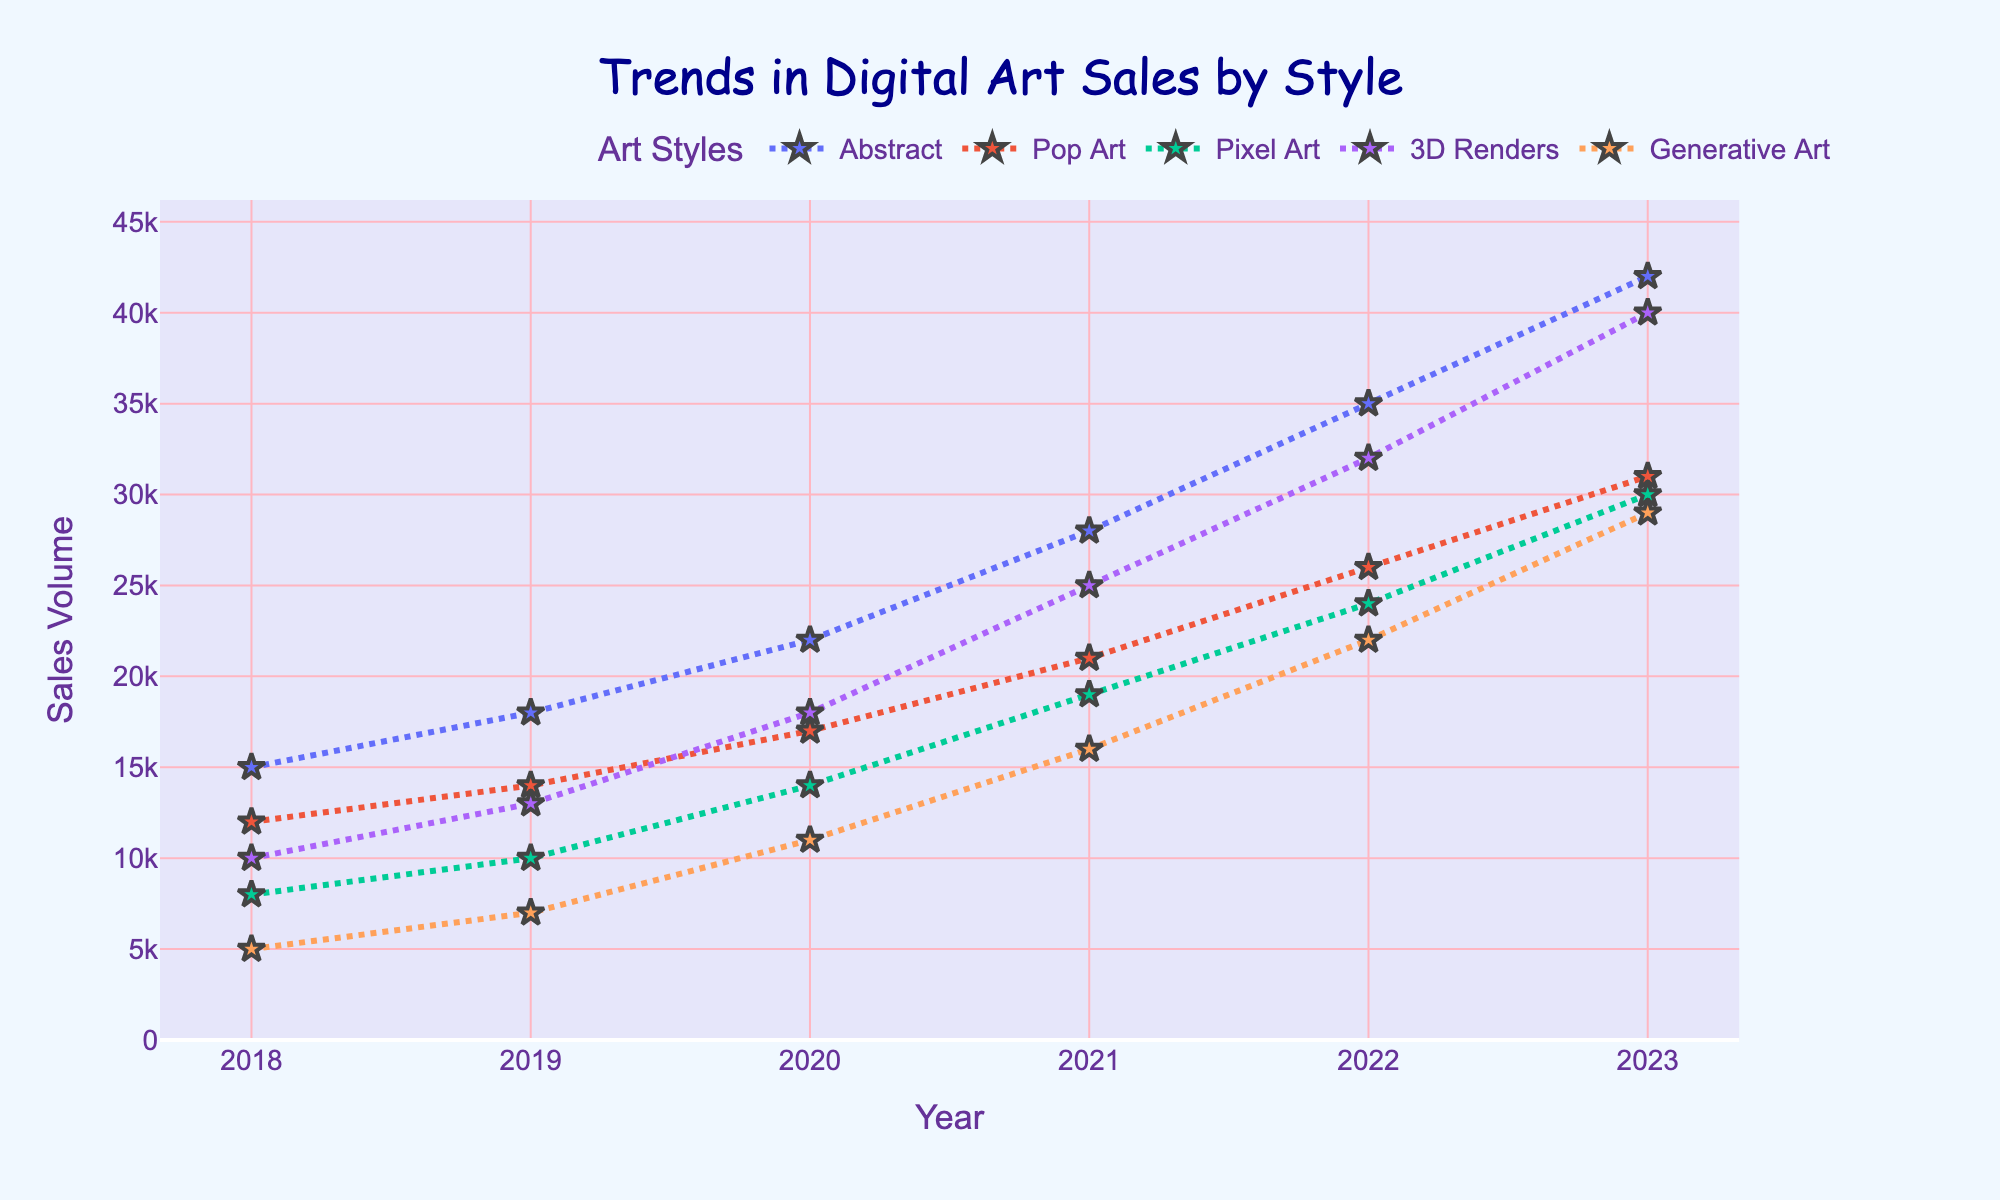What art style had the highest sales in 2023? The art style with the highest sales in 2023 is identified by looking at the peaks of the lines in the final year on the x-axis. The highest point corresponds to "3D Renders."
Answer: 3D Renders Which art style showed the most consistent growth from 2018 to 2023? Consistent growth is observed by seeing if the line graph for the art style steadily increases year-over-year without any declines. "Abstract" shows continuous and steady growth.
Answer: Abstract What is the difference in sales between Pixel Art and Generative Art in 2022? First, find the sales values for Pixel Art (24000) and Generative Art (22000) in 2022. Then calculate the difference: 24000 - 22000 = 2000.
Answer: 2000 Which two art styles had nearly equal sales in 2019? Identify the lines that are closest in height in 2019. Both Pop Art (14000) and Pixel Art (10000) compared with Generative Art (7000) are not close. The closest are Pop Art (14000) and 3D Renders (13000).
Answer: Pop Art and 3D Renders How did the sales volume for Generative Art change between 2020 and 2021? Look at the sales volume for Generative Art in 2020 (11000) and 2021 (16000). Calculate the change: 16000 - 11000 = 5000.
Answer: Increased by 5000 Which year saw the highest increase in sales for Abstract art? Check the differences year-to-year for Abstract art:
2018-2019: 18000 - 15000 = 3000
2019-2020: 22000 - 18000 = 4000
2020-2021: 28000 - 22000 = 6000
2021-2022: 35000 - 28000 = 7000
2022-2023: 42000 - 35000 = 7000
The highest increase is 7000, observed in both 2021-2022 and 2022-2023.
Answer: 2021-2022 and 2022-2023 What was the overall trend for Pop Art sales from 2018 to 2023? The line representing Pop Art increases every year from 12000 in 2018 to 31000 in 2023, indicating a consistent upward trend.
Answer: Upward trend Which art style saw the least amount of sales growth between 2018 and 2019? Calculate the growth for each art style from 2018-2019:
Abstract: 18000 - 15000 = 3000
Pop Art: 14000 - 12000 = 2000
Pixel Art: 10000 - 8000 = 2000
3D Renders: 13000 - 10000 = 3000
Generative Art: 7000 - 5000 = 2000
The least growth is observed in Pop Art, Pixel Art, and Generative Art (2000 each).
Answer: Pop Art, Pixel Art, Generative Art 